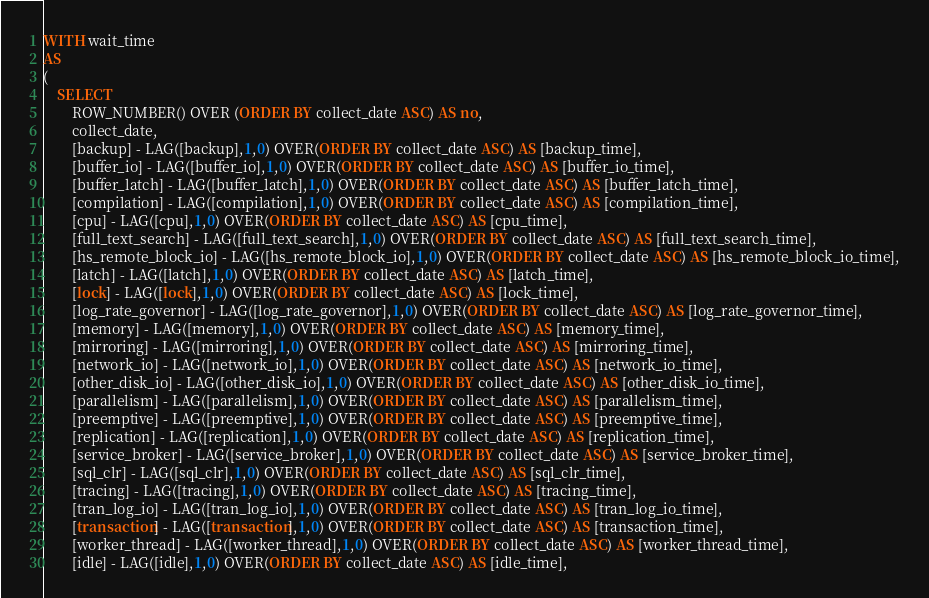Convert code to text. <code><loc_0><loc_0><loc_500><loc_500><_SQL_>WITH wait_time
AS
(
    SELECT
        ROW_NUMBER() OVER (ORDER BY collect_date ASC) AS no,
        collect_date,
        [backup] - LAG([backup],1,0) OVER(ORDER BY collect_date ASC) AS [backup_time],
        [buffer_io] - LAG([buffer_io],1,0) OVER(ORDER BY collect_date ASC) AS [buffer_io_time],
        [buffer_latch] - LAG([buffer_latch],1,0) OVER(ORDER BY collect_date ASC) AS [buffer_latch_time],
        [compilation] - LAG([compilation],1,0) OVER(ORDER BY collect_date ASC) AS [compilation_time],
        [cpu] - LAG([cpu],1,0) OVER(ORDER BY collect_date ASC) AS [cpu_time],
        [full_text_search] - LAG([full_text_search],1,0) OVER(ORDER BY collect_date ASC) AS [full_text_search_time],
        [hs_remote_block_io] - LAG([hs_remote_block_io],1,0) OVER(ORDER BY collect_date ASC) AS [hs_remote_block_io_time],
        [latch] - LAG([latch],1,0) OVER(ORDER BY collect_date ASC) AS [latch_time],
        [lock] - LAG([lock],1,0) OVER(ORDER BY collect_date ASC) AS [lock_time],
        [log_rate_governor] - LAG([log_rate_governor],1,0) OVER(ORDER BY collect_date ASC) AS [log_rate_governor_time],
        [memory] - LAG([memory],1,0) OVER(ORDER BY collect_date ASC) AS [memory_time],
        [mirroring] - LAG([mirroring],1,0) OVER(ORDER BY collect_date ASC) AS [mirroring_time],
        [network_io] - LAG([network_io],1,0) OVER(ORDER BY collect_date ASC) AS [network_io_time],
        [other_disk_io] - LAG([other_disk_io],1,0) OVER(ORDER BY collect_date ASC) AS [other_disk_io_time],
        [parallelism] - LAG([parallelism],1,0) OVER(ORDER BY collect_date ASC) AS [parallelism_time],
        [preemptive] - LAG([preemptive],1,0) OVER(ORDER BY collect_date ASC) AS [preemptive_time],
        [replication] - LAG([replication],1,0) OVER(ORDER BY collect_date ASC) AS [replication_time],
        [service_broker] - LAG([service_broker],1,0) OVER(ORDER BY collect_date ASC) AS [service_broker_time],
        [sql_clr] - LAG([sql_clr],1,0) OVER(ORDER BY collect_date ASC) AS [sql_clr_time],
        [tracing] - LAG([tracing],1,0) OVER(ORDER BY collect_date ASC) AS [tracing_time],
        [tran_log_io] - LAG([tran_log_io],1,0) OVER(ORDER BY collect_date ASC) AS [tran_log_io_time],
        [transaction] - LAG([transaction],1,0) OVER(ORDER BY collect_date ASC) AS [transaction_time],
        [worker_thread] - LAG([worker_thread],1,0) OVER(ORDER BY collect_date ASC) AS [worker_thread_time],
        [idle] - LAG([idle],1,0) OVER(ORDER BY collect_date ASC) AS [idle_time],</code> 